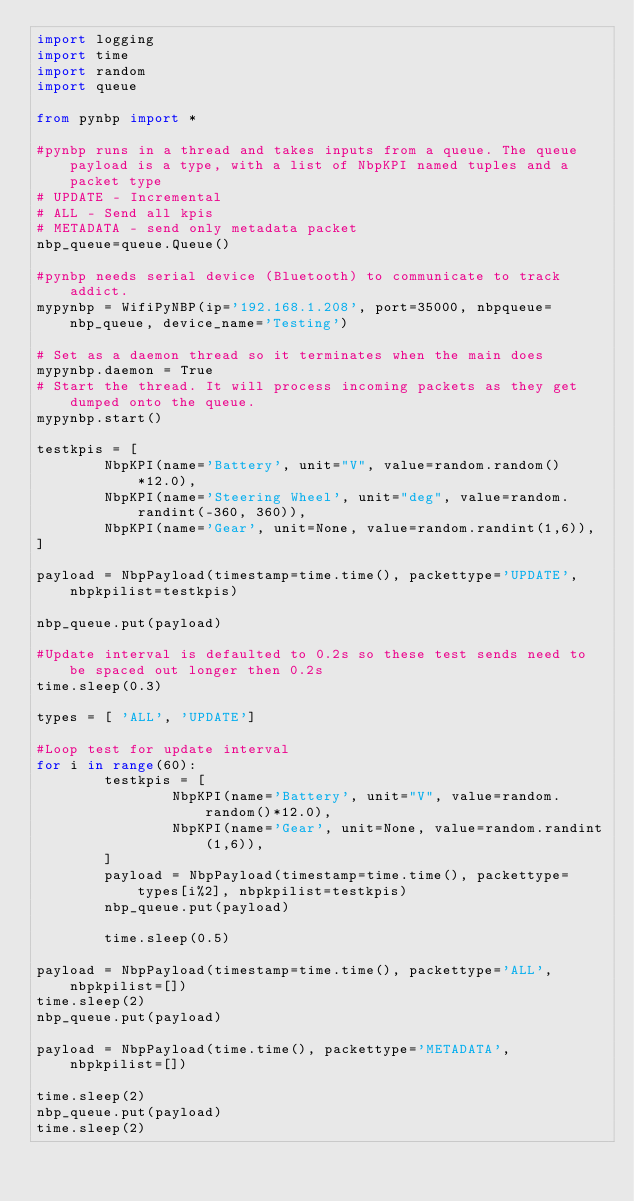Convert code to text. <code><loc_0><loc_0><loc_500><loc_500><_Python_>import logging
import time
import random
import queue

from pynbp import *

#pynbp runs in a thread and takes inputs from a queue. The queue payload is a type, with a list of NbpKPI named tuples and a packet type
# UPDATE - Incremental
# ALL - Send all kpis
# METADATA - send only metadata packet
nbp_queue=queue.Queue()

#pynbp needs serial device (Bluetooth) to communicate to track addict.
mypynbp = WifiPyNBP(ip='192.168.1.208', port=35000, nbpqueue=nbp_queue, device_name='Testing')

# Set as a daemon thread so it terminates when the main does
mypynbp.daemon = True
# Start the thread. It will process incoming packets as they get dumped onto the queue.
mypynbp.start()

testkpis = [
        NbpKPI(name='Battery', unit="V", value=random.random()*12.0),
        NbpKPI(name='Steering Wheel', unit="deg", value=random.randint(-360, 360)),
        NbpKPI(name='Gear', unit=None, value=random.randint(1,6)),
]

payload = NbpPayload(timestamp=time.time(), packettype='UPDATE', nbpkpilist=testkpis)

nbp_queue.put(payload)

#Update interval is defaulted to 0.2s so these test sends need to be spaced out longer then 0.2s
time.sleep(0.3)

types = [ 'ALL', 'UPDATE']

#Loop test for update interval
for i in range(60):
        testkpis = [
                NbpKPI(name='Battery', unit="V", value=random.random()*12.0),
                NbpKPI(name='Gear', unit=None, value=random.randint(1,6)),
        ]
        payload = NbpPayload(timestamp=time.time(), packettype=types[i%2], nbpkpilist=testkpis)
        nbp_queue.put(payload)

        time.sleep(0.5)

payload = NbpPayload(timestamp=time.time(), packettype='ALL', nbpkpilist=[])
time.sleep(2)
nbp_queue.put(payload)

payload = NbpPayload(time.time(), packettype='METADATA',  nbpkpilist=[])

time.sleep(2)
nbp_queue.put(payload)
time.sleep(2)
</code> 